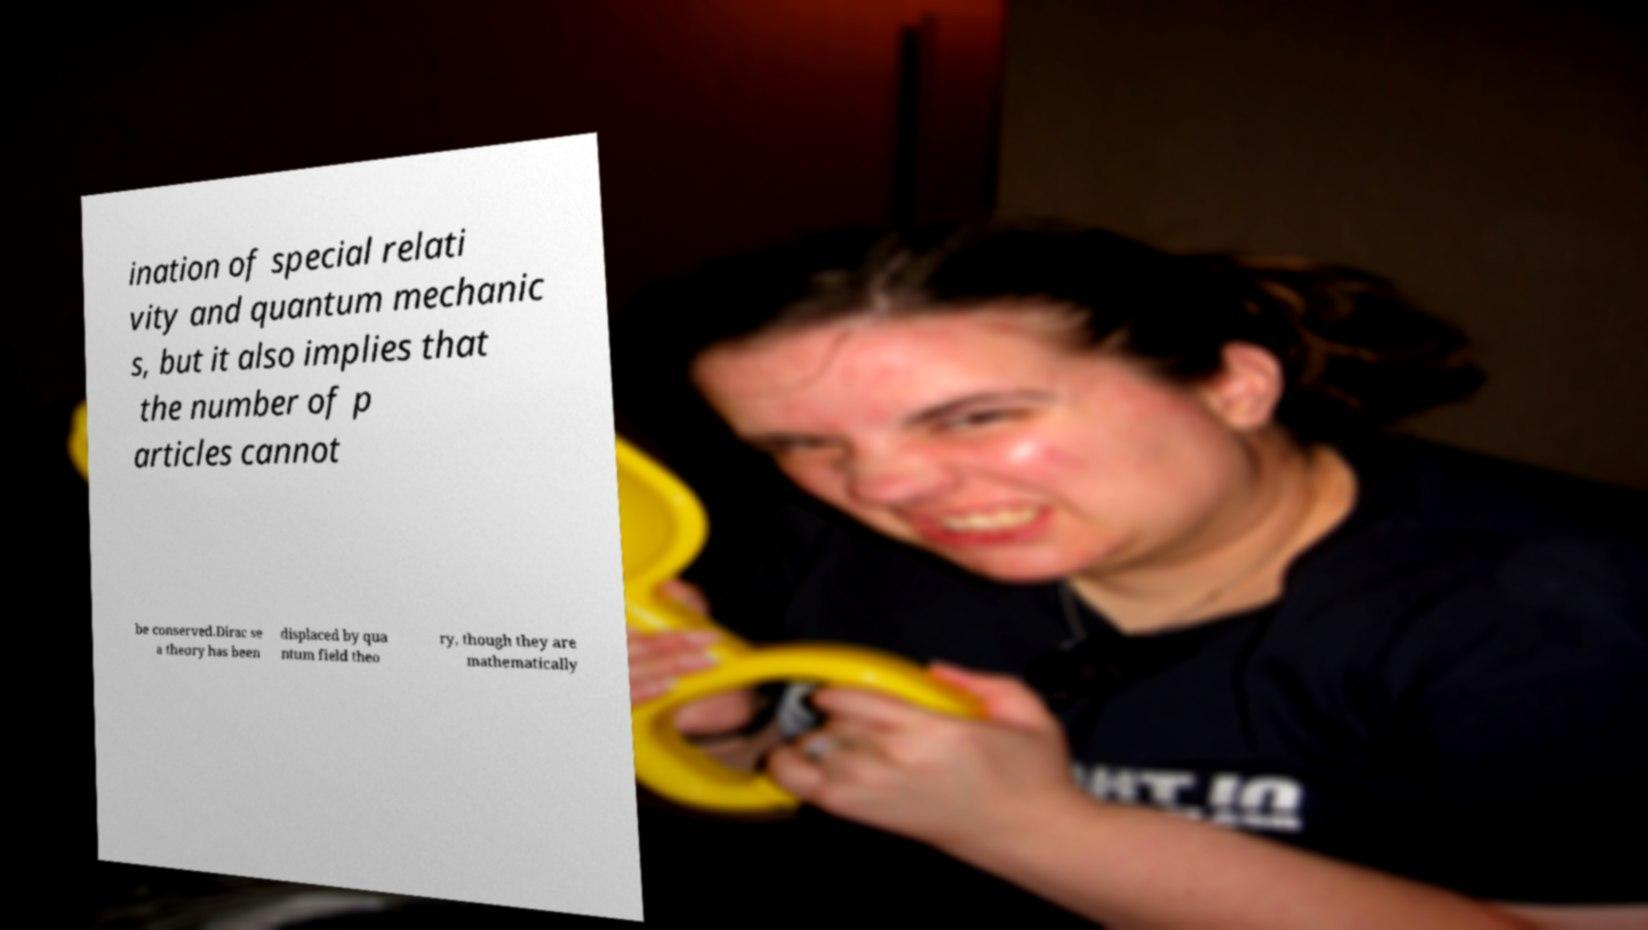Please read and relay the text visible in this image. What does it say? ination of special relati vity and quantum mechanic s, but it also implies that the number of p articles cannot be conserved.Dirac se a theory has been displaced by qua ntum field theo ry, though they are mathematically 